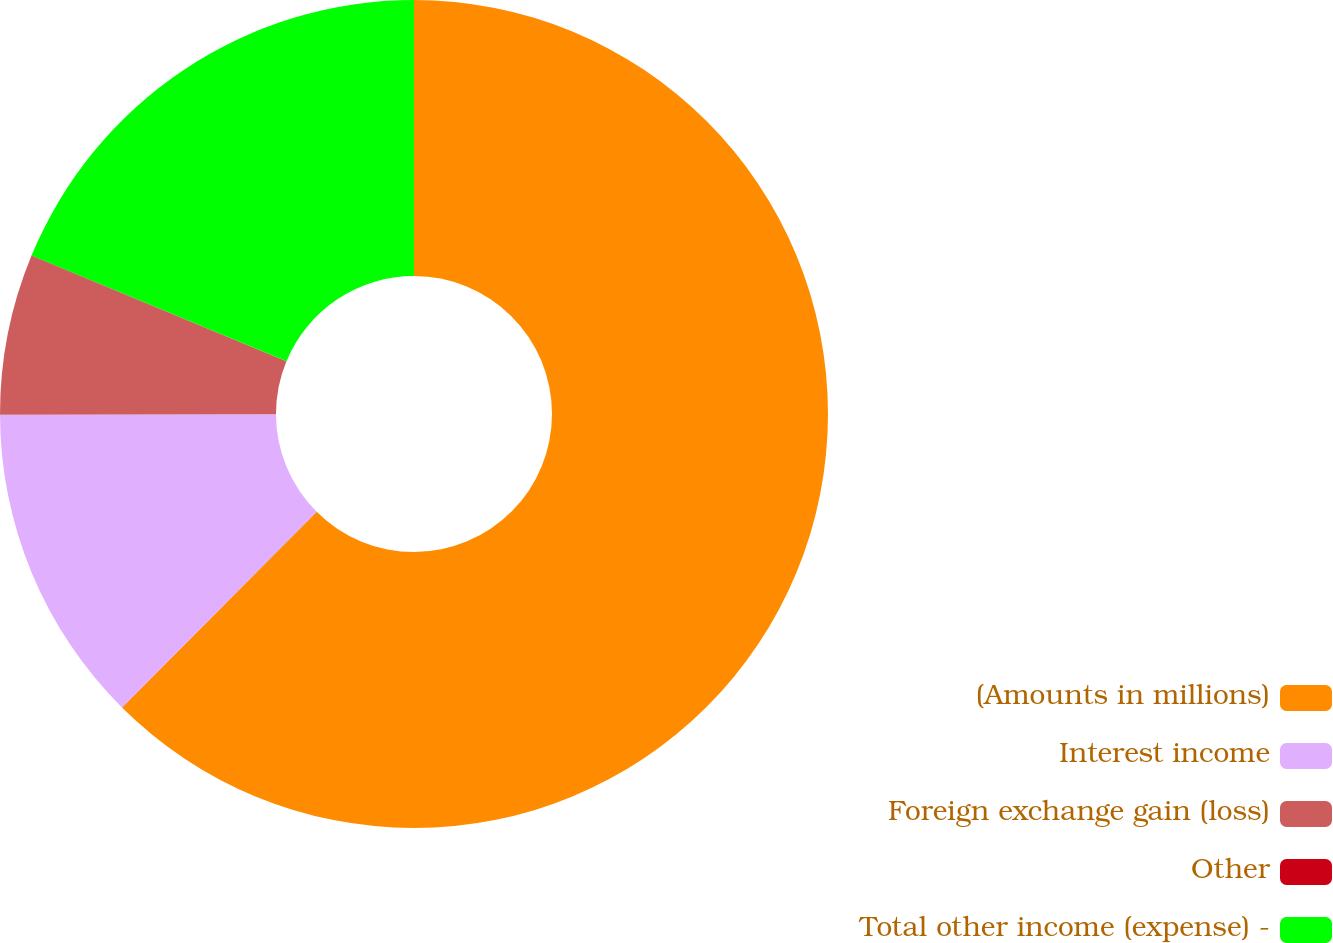<chart> <loc_0><loc_0><loc_500><loc_500><pie_chart><fcel>(Amounts in millions)<fcel>Interest income<fcel>Foreign exchange gain (loss)<fcel>Other<fcel>Total other income (expense) -<nl><fcel>62.46%<fcel>12.51%<fcel>6.26%<fcel>0.02%<fcel>18.75%<nl></chart> 